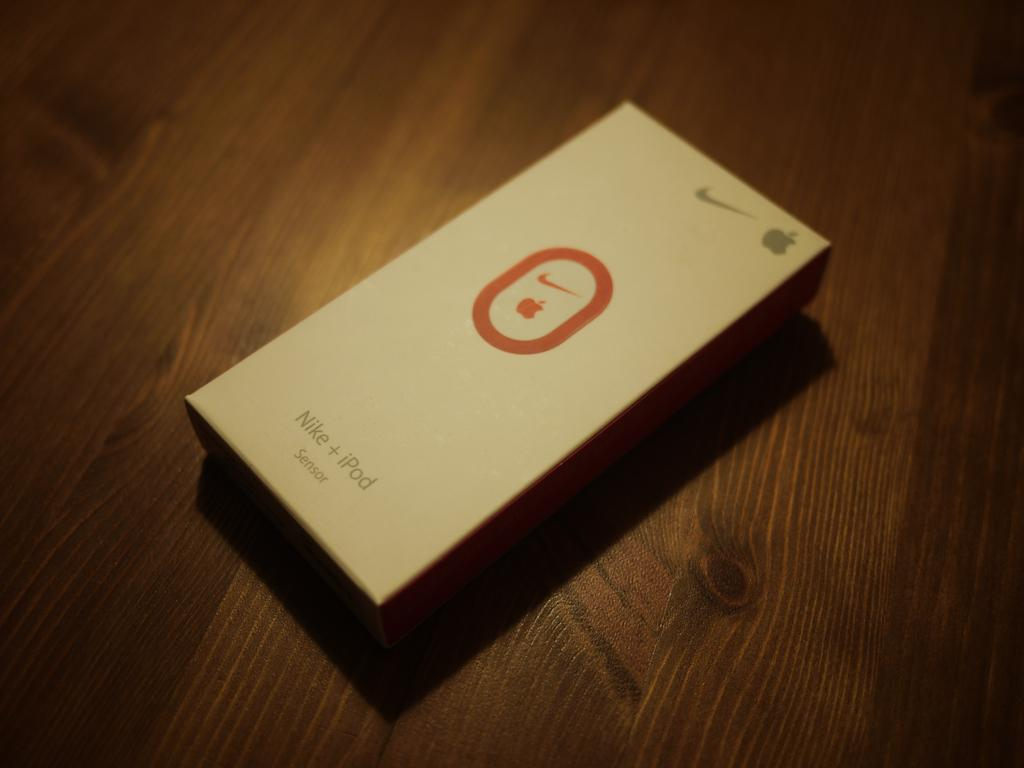What is the main object in the image? There is a gadget in the image. Where is the gadget located? The gadget is in a box. What is the box placed on? The box is on a wooden surface. How many turkeys are visible in the image? There are no turkeys present in the image. Is there a hose connected to the gadget in the image? There is no hose connected to the gadget in the image. 